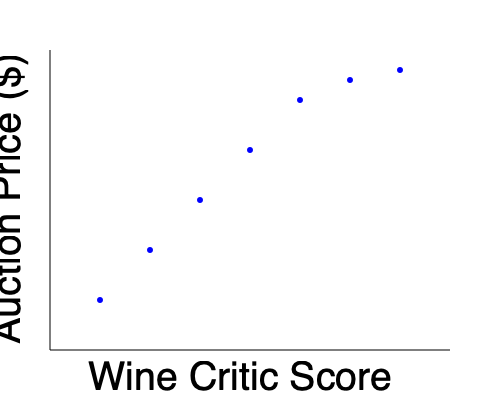Based on the scatter plot showing the relationship between wine critic scores and auction prices, what type of correlation is observed, and how might this information influence your investment strategy in rare and collectible wines? To answer this question, let's analyze the scatter plot step-by-step:

1. Observe the overall trend: As we move from left to right (increasing wine critic scores), the points generally move upward (increasing auction prices).

2. Identify the correlation type: This upward trend indicates a negative correlation between wine critic scores and auction prices. As critic scores increase, auction prices tend to increase as well.

3. Assess the strength of the correlation: The points form a relatively tight pattern around an imaginary line, suggesting a strong correlation.

4. Consider the implications for investment:
   a) Higher-rated wines tend to command higher prices at auction.
   b) Wines with exceptional critic scores may offer the best potential for investment appreciation.
   c) Lower-rated wines might present opportunities for undervalued acquisitions, but may carry more risk.

5. Develop an investment strategy:
   a) Focus on acquiring wines with high critic scores, as they are likely to fetch higher prices at auction.
   b) Monitor critic scores of wines in your collection to identify optimal selling opportunities.
   c) Consider diversifying your portfolio with a mix of high-scoring wines and potential "sleeper" wines that may be undervalued.

Given this analysis, an effective investment strategy would prioritize wines with high critic scores while also keeping an eye out for undervalued wines with potential for appreciation.
Answer: Strong negative correlation; prioritize high-scoring wines for investment while considering undervalued opportunities. 